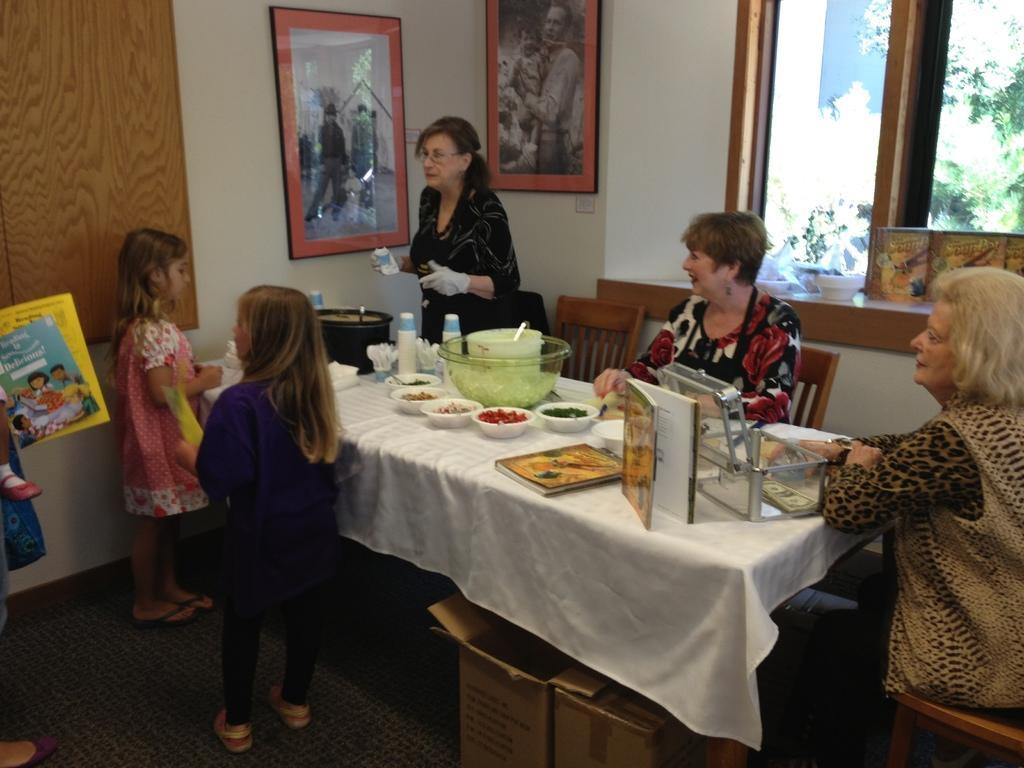In one or two sentences, can you explain what this image depicts? As we can see in the image, there are few people. These three people are standing and these two people are sitting on chairs and there is a table over here. On table there is a white color cloth, bowls, bottle and big bowl. Behind them there is a wall. On the wall there are two photo frames and on the right side there is a window. 